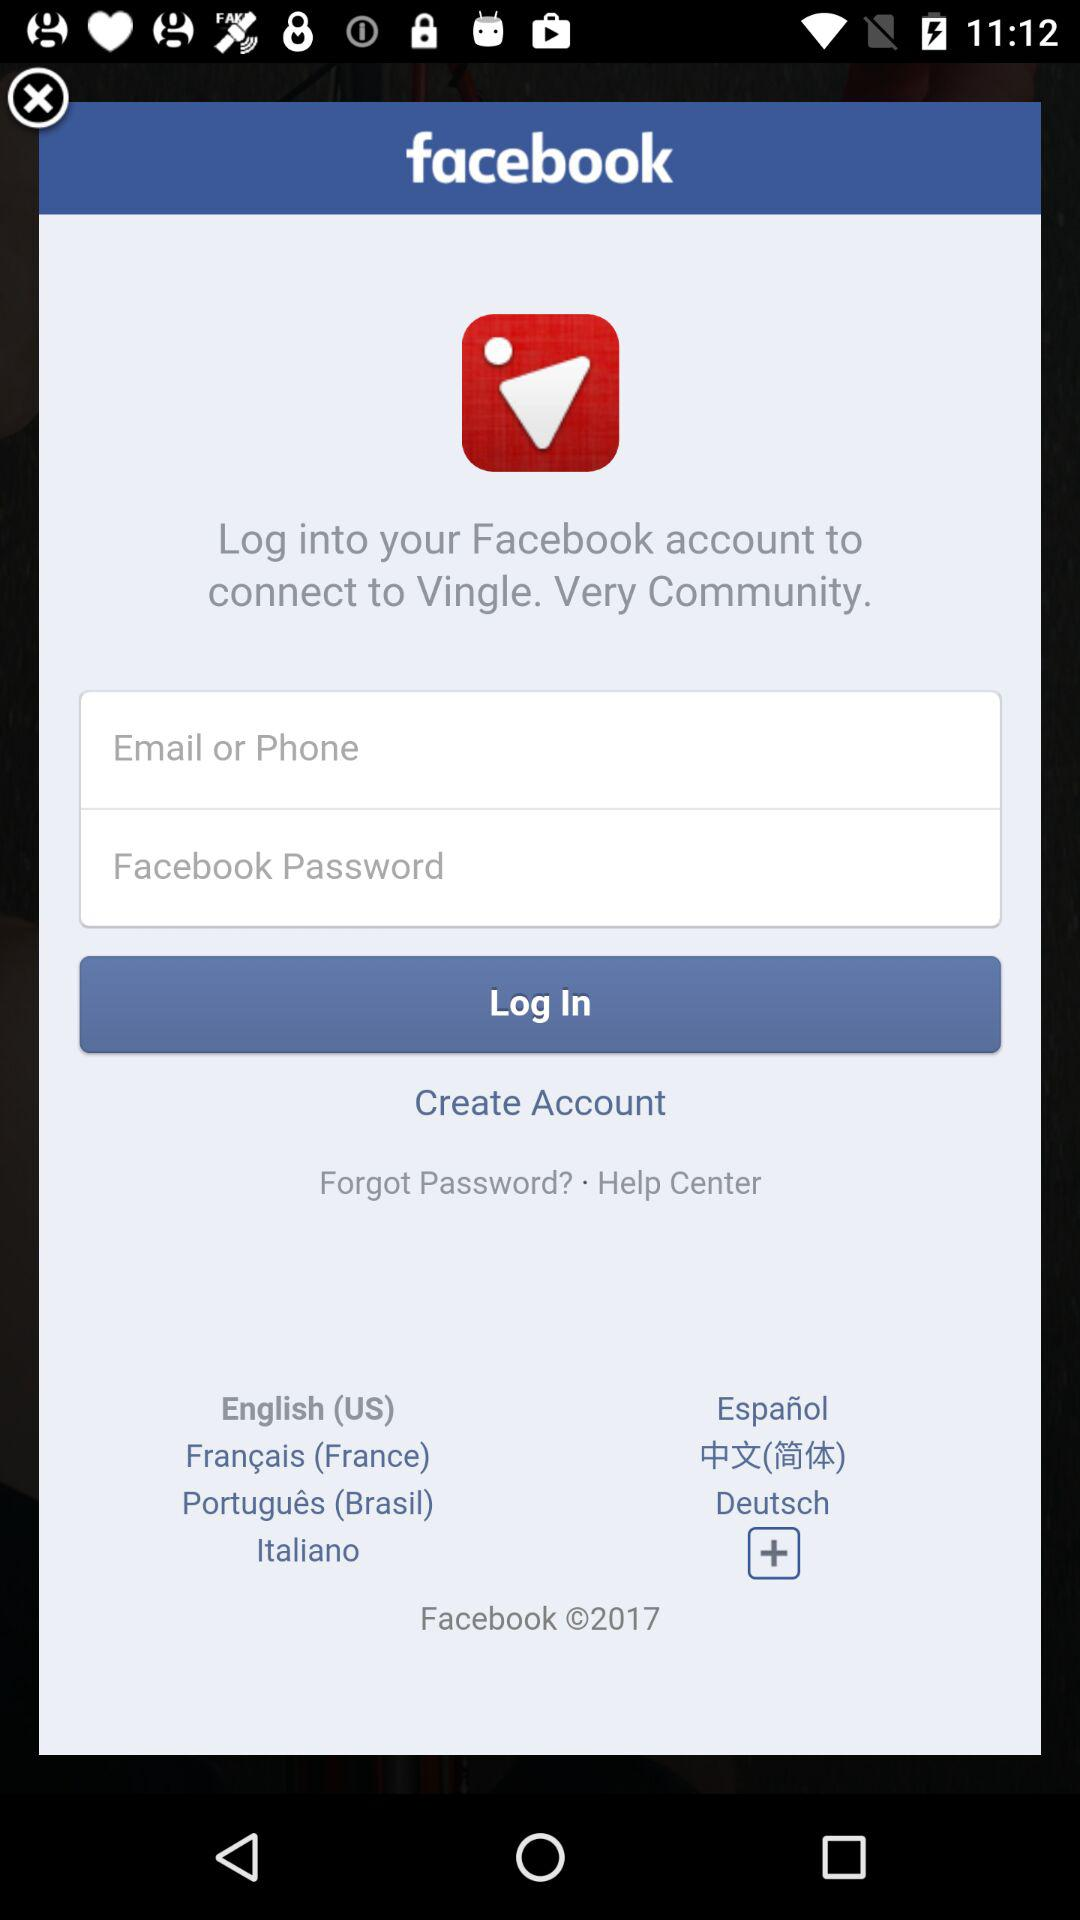What is the app name? The app name is "Vingle. Very Community.". 